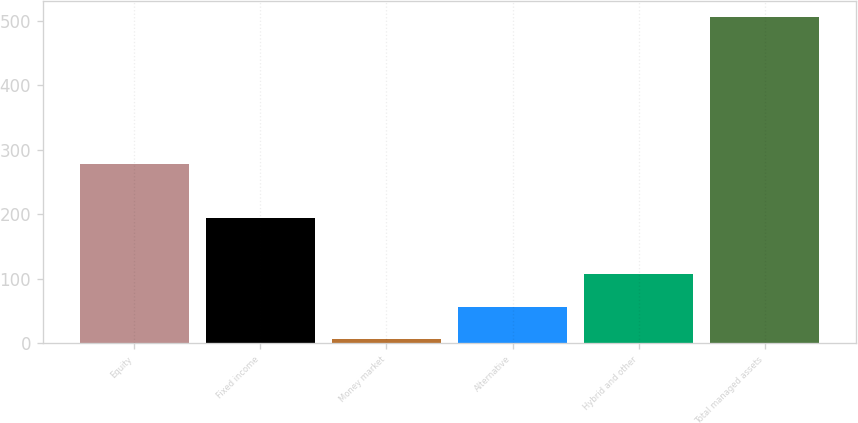Convert chart to OTSL. <chart><loc_0><loc_0><loc_500><loc_500><bar_chart><fcel>Equity<fcel>Fixed income<fcel>Money market<fcel>Alternative<fcel>Hybrid and other<fcel>Total managed assets<nl><fcel>278.1<fcel>193.4<fcel>6.7<fcel>56.59<fcel>106.48<fcel>505.6<nl></chart> 